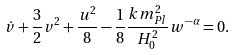<formula> <loc_0><loc_0><loc_500><loc_500>\dot { v } + \frac { 3 } { 2 } v ^ { 2 } + \frac { u ^ { 2 } } { 8 } - \frac { 1 } { 8 } \frac { k m _ { P l } ^ { 2 } } { H _ { 0 } ^ { 2 } } w ^ { - \alpha } = 0 .</formula> 